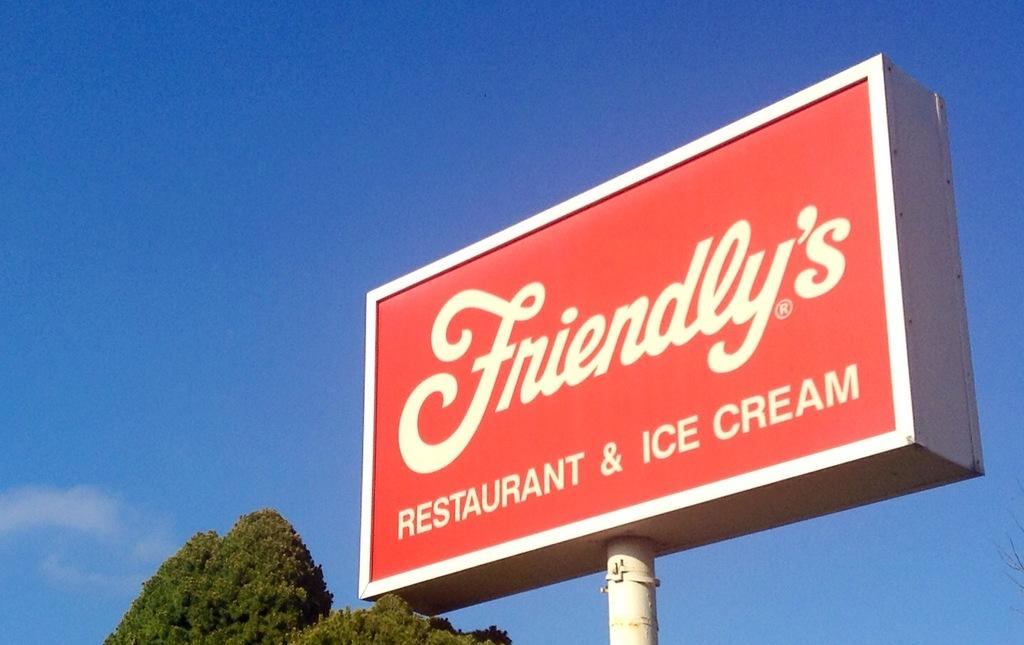<image>
Create a compact narrative representing the image presented. A red and white Friendly's restaurant sign indicates that they also specalise in ice-cream. 